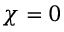Convert formula to latex. <formula><loc_0><loc_0><loc_500><loc_500>\chi = 0</formula> 